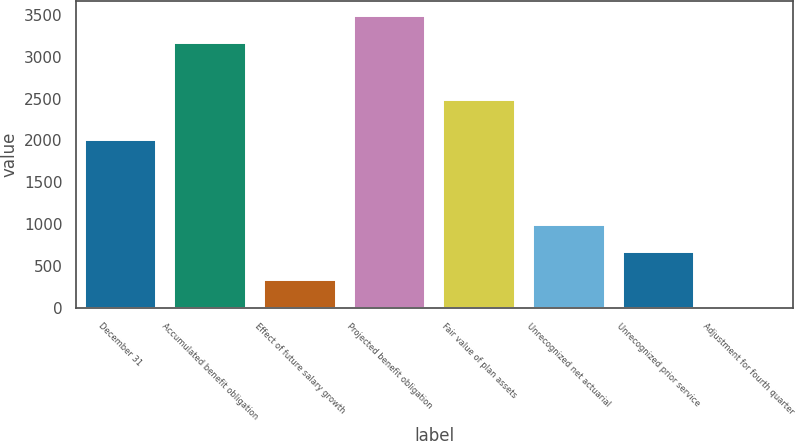Convert chart. <chart><loc_0><loc_0><loc_500><loc_500><bar_chart><fcel>December 31<fcel>Accumulated benefit obligation<fcel>Effect of future salary growth<fcel>Projected benefit obligation<fcel>Fair value of plan assets<fcel>Unrecognized net actuarial<fcel>Unrecognized prior service<fcel>Adjustment for fourth quarter<nl><fcel>2001<fcel>3159<fcel>336.4<fcel>3488.4<fcel>2481<fcel>995.2<fcel>665.8<fcel>7<nl></chart> 